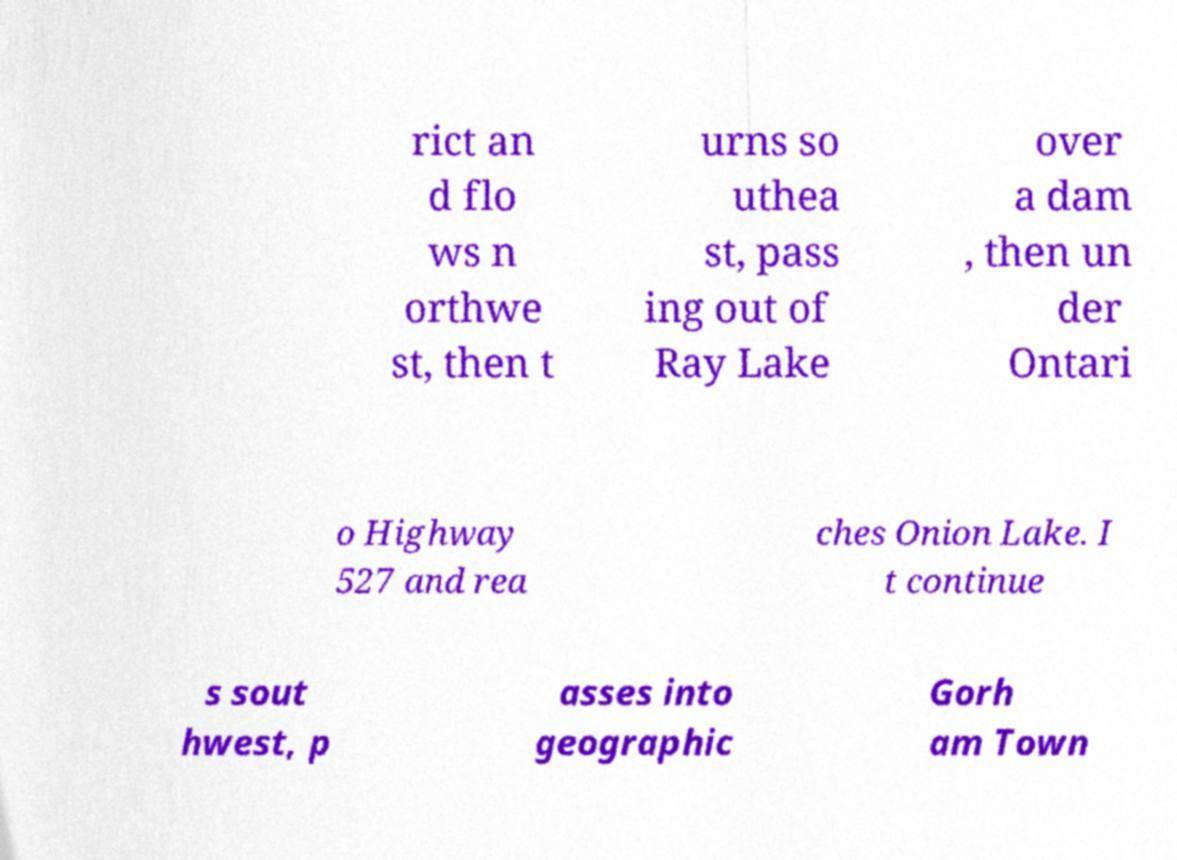What messages or text are displayed in this image? I need them in a readable, typed format. rict an d flo ws n orthwe st, then t urns so uthea st, pass ing out of Ray Lake over a dam , then un der Ontari o Highway 527 and rea ches Onion Lake. I t continue s sout hwest, p asses into geographic Gorh am Town 